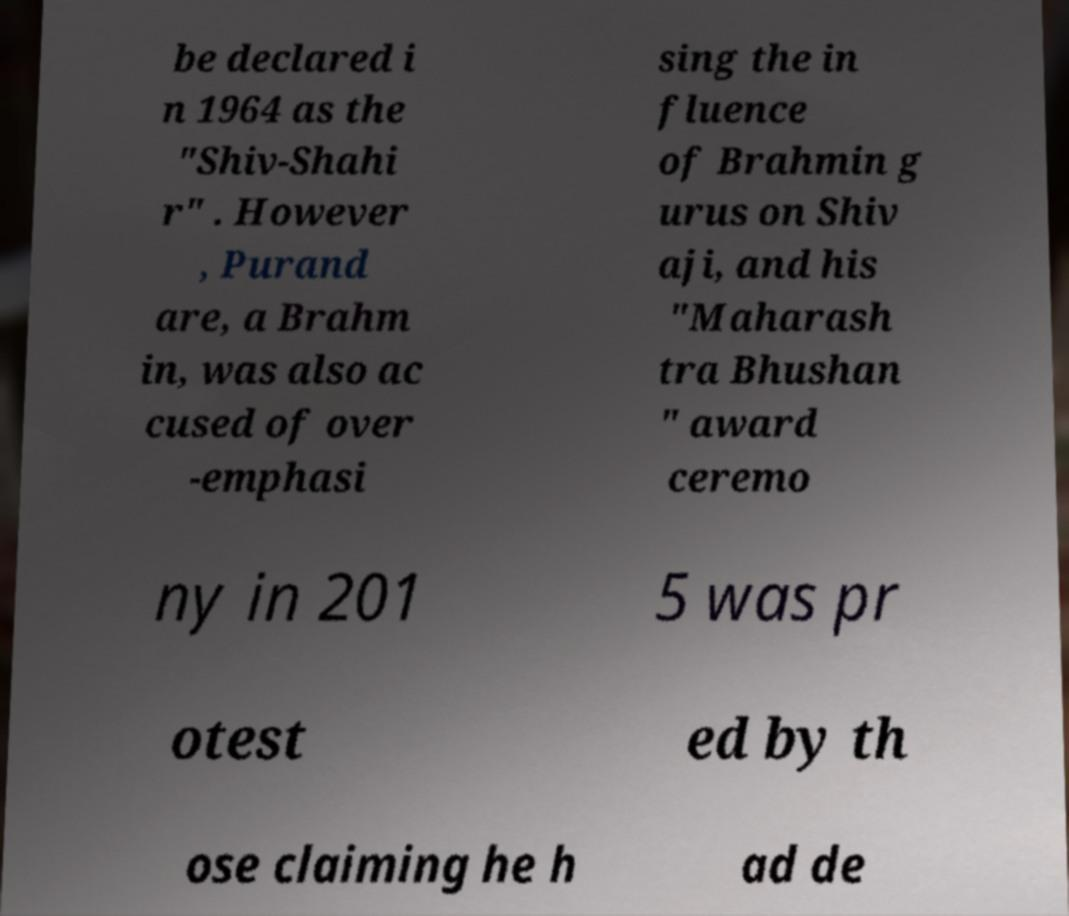Please read and relay the text visible in this image. What does it say? be declared i n 1964 as the "Shiv-Shahi r" . However , Purand are, a Brahm in, was also ac cused of over -emphasi sing the in fluence of Brahmin g urus on Shiv aji, and his "Maharash tra Bhushan " award ceremo ny in 201 5 was pr otest ed by th ose claiming he h ad de 